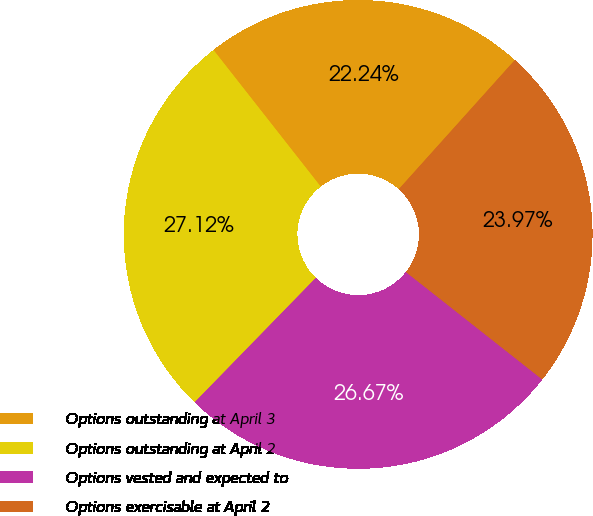Convert chart to OTSL. <chart><loc_0><loc_0><loc_500><loc_500><pie_chart><fcel>Options outstanding at April 3<fcel>Options outstanding at April 2<fcel>Options vested and expected to<fcel>Options exercisable at April 2<nl><fcel>22.24%<fcel>27.12%<fcel>26.67%<fcel>23.97%<nl></chart> 